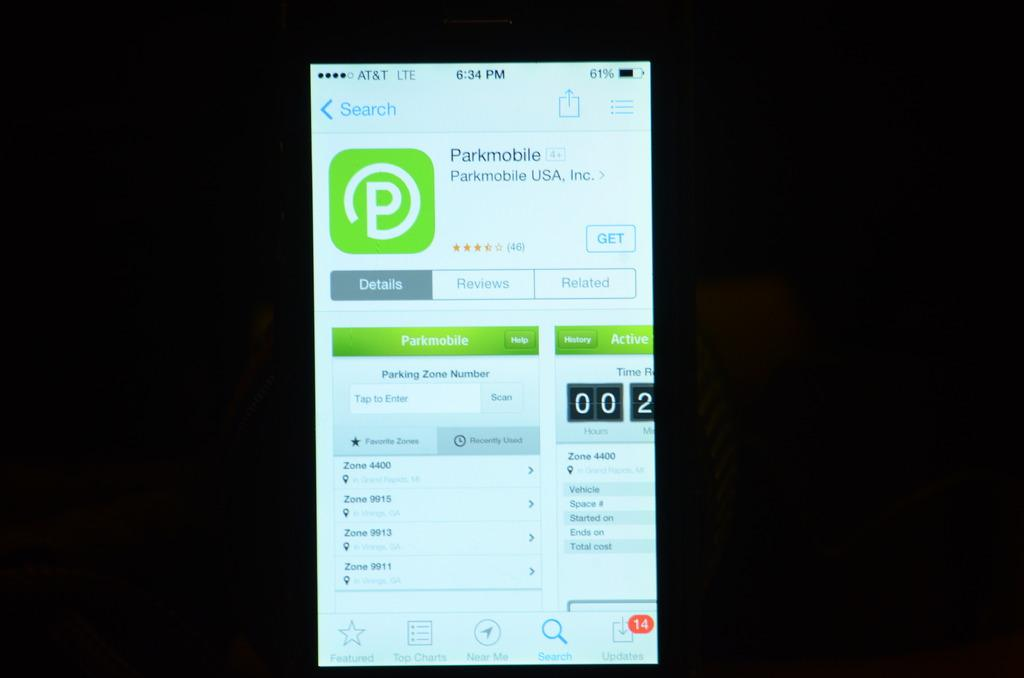<image>
Present a compact description of the photo's key features. Smartphone screen displaying option to download the Parkmobile App. 